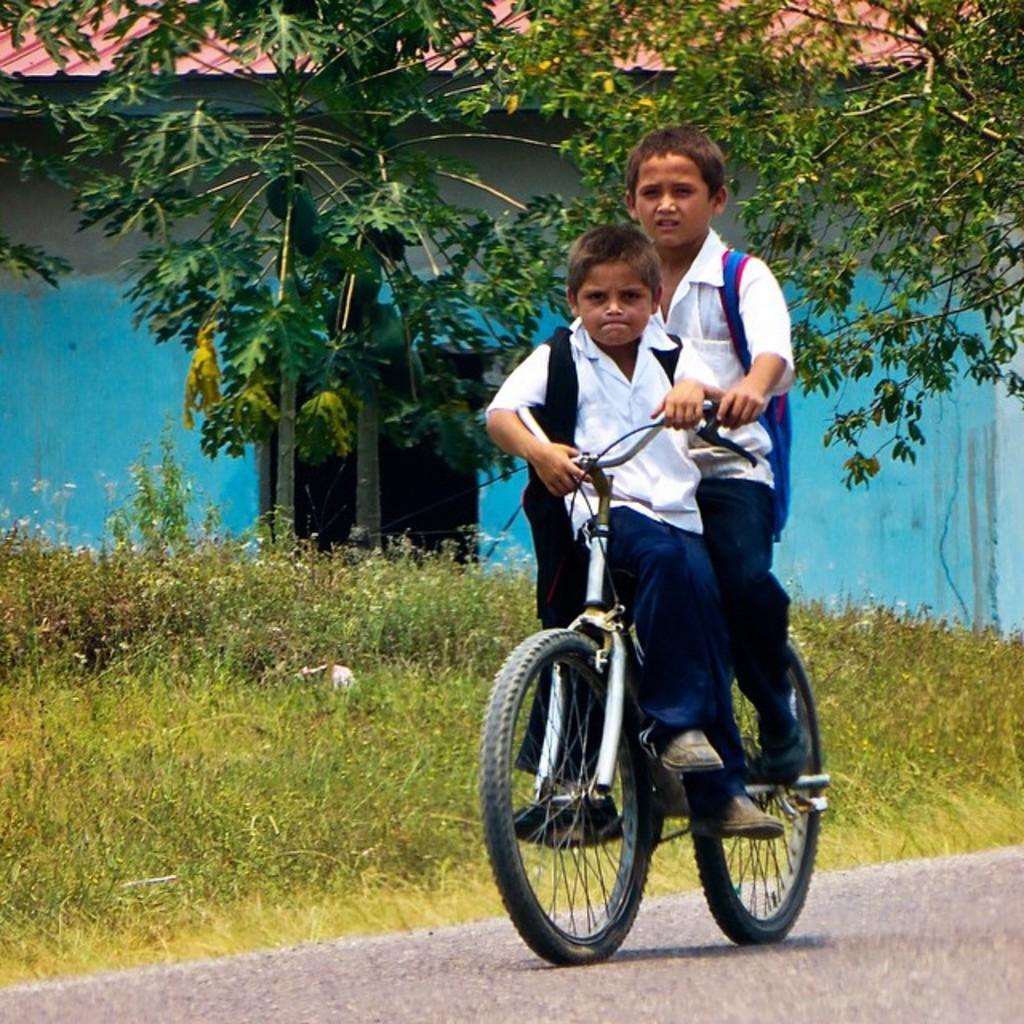Could you give a brief overview of what you see in this image? In this picture there are two boys riding on a bi-cycle and in the backdrop there is grass, plants, papaya trees and there is a building with the roof. 